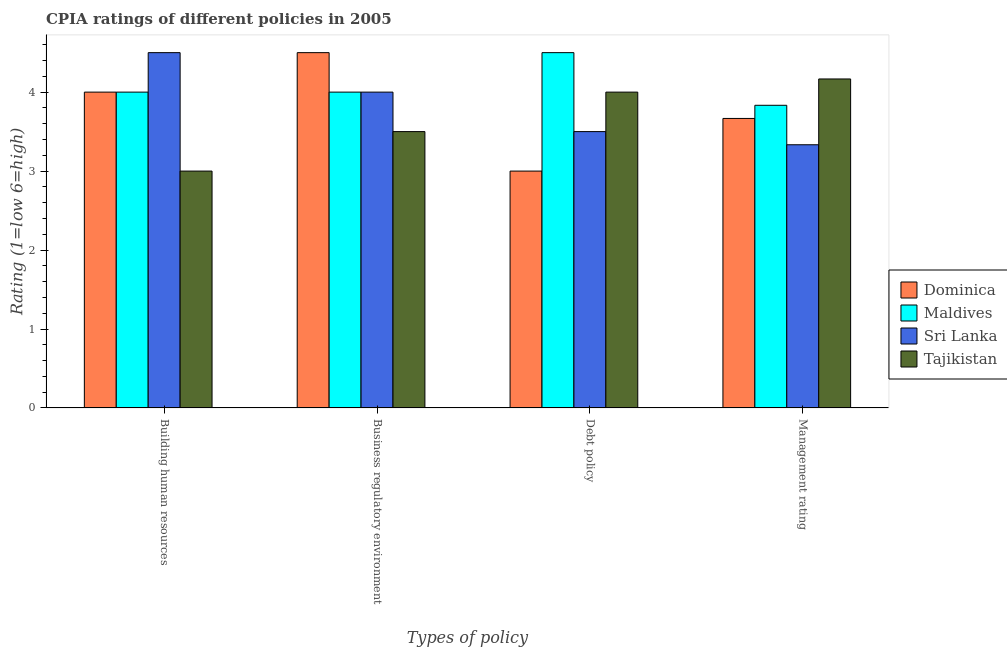Are the number of bars per tick equal to the number of legend labels?
Provide a succinct answer. Yes. How many bars are there on the 3rd tick from the right?
Your answer should be compact. 4. What is the label of the 4th group of bars from the left?
Your answer should be very brief. Management rating. What is the cpia rating of building human resources in Dominica?
Give a very brief answer. 4. Across all countries, what is the maximum cpia rating of management?
Keep it short and to the point. 4.17. In which country was the cpia rating of business regulatory environment maximum?
Ensure brevity in your answer.  Dominica. In which country was the cpia rating of building human resources minimum?
Your answer should be compact. Tajikistan. What is the total cpia rating of building human resources in the graph?
Offer a terse response. 15.5. What is the difference between the cpia rating of building human resources in Sri Lanka and that in Maldives?
Provide a succinct answer. 0.5. What is the difference between the cpia rating of business regulatory environment in Maldives and the cpia rating of management in Tajikistan?
Ensure brevity in your answer.  -0.17. What is the difference between the cpia rating of building human resources and cpia rating of debt policy in Dominica?
Make the answer very short. 1. What is the ratio of the cpia rating of debt policy in Maldives to that in Sri Lanka?
Make the answer very short. 1.29. What is the difference between the highest and the second highest cpia rating of management?
Provide a short and direct response. 0.33. What is the difference between the highest and the lowest cpia rating of business regulatory environment?
Your response must be concise. 1. Is the sum of the cpia rating of management in Maldives and Sri Lanka greater than the maximum cpia rating of debt policy across all countries?
Your answer should be compact. Yes. What does the 2nd bar from the left in Business regulatory environment represents?
Offer a very short reply. Maldives. What does the 3rd bar from the right in Building human resources represents?
Your answer should be very brief. Maldives. How many bars are there?
Ensure brevity in your answer.  16. Are the values on the major ticks of Y-axis written in scientific E-notation?
Ensure brevity in your answer.  No. Does the graph contain any zero values?
Give a very brief answer. No. Does the graph contain grids?
Your answer should be very brief. No. How many legend labels are there?
Provide a short and direct response. 4. How are the legend labels stacked?
Ensure brevity in your answer.  Vertical. What is the title of the graph?
Provide a succinct answer. CPIA ratings of different policies in 2005. What is the label or title of the X-axis?
Provide a short and direct response. Types of policy. What is the label or title of the Y-axis?
Give a very brief answer. Rating (1=low 6=high). What is the Rating (1=low 6=high) of Sri Lanka in Building human resources?
Provide a succinct answer. 4.5. What is the Rating (1=low 6=high) in Tajikistan in Building human resources?
Ensure brevity in your answer.  3. What is the Rating (1=low 6=high) of Sri Lanka in Business regulatory environment?
Offer a very short reply. 4. What is the Rating (1=low 6=high) in Dominica in Debt policy?
Ensure brevity in your answer.  3. What is the Rating (1=low 6=high) in Maldives in Debt policy?
Ensure brevity in your answer.  4.5. What is the Rating (1=low 6=high) in Tajikistan in Debt policy?
Your answer should be compact. 4. What is the Rating (1=low 6=high) in Dominica in Management rating?
Your answer should be compact. 3.67. What is the Rating (1=low 6=high) in Maldives in Management rating?
Offer a very short reply. 3.83. What is the Rating (1=low 6=high) in Sri Lanka in Management rating?
Keep it short and to the point. 3.33. What is the Rating (1=low 6=high) of Tajikistan in Management rating?
Give a very brief answer. 4.17. Across all Types of policy, what is the maximum Rating (1=low 6=high) in Maldives?
Your answer should be compact. 4.5. Across all Types of policy, what is the maximum Rating (1=low 6=high) of Sri Lanka?
Keep it short and to the point. 4.5. Across all Types of policy, what is the maximum Rating (1=low 6=high) of Tajikistan?
Keep it short and to the point. 4.17. Across all Types of policy, what is the minimum Rating (1=low 6=high) in Dominica?
Ensure brevity in your answer.  3. Across all Types of policy, what is the minimum Rating (1=low 6=high) of Maldives?
Provide a succinct answer. 3.83. Across all Types of policy, what is the minimum Rating (1=low 6=high) in Sri Lanka?
Give a very brief answer. 3.33. What is the total Rating (1=low 6=high) in Dominica in the graph?
Your response must be concise. 15.17. What is the total Rating (1=low 6=high) in Maldives in the graph?
Your response must be concise. 16.33. What is the total Rating (1=low 6=high) in Sri Lanka in the graph?
Keep it short and to the point. 15.33. What is the total Rating (1=low 6=high) of Tajikistan in the graph?
Your response must be concise. 14.67. What is the difference between the Rating (1=low 6=high) in Dominica in Building human resources and that in Business regulatory environment?
Provide a succinct answer. -0.5. What is the difference between the Rating (1=low 6=high) in Tajikistan in Building human resources and that in Business regulatory environment?
Your answer should be very brief. -0.5. What is the difference between the Rating (1=low 6=high) in Maldives in Building human resources and that in Debt policy?
Give a very brief answer. -0.5. What is the difference between the Rating (1=low 6=high) in Dominica in Building human resources and that in Management rating?
Make the answer very short. 0.33. What is the difference between the Rating (1=low 6=high) of Tajikistan in Building human resources and that in Management rating?
Give a very brief answer. -1.17. What is the difference between the Rating (1=low 6=high) in Tajikistan in Business regulatory environment and that in Debt policy?
Offer a very short reply. -0.5. What is the difference between the Rating (1=low 6=high) in Dominica in Business regulatory environment and that in Management rating?
Offer a terse response. 0.83. What is the difference between the Rating (1=low 6=high) of Maldives in Business regulatory environment and that in Management rating?
Offer a very short reply. 0.17. What is the difference between the Rating (1=low 6=high) in Sri Lanka in Business regulatory environment and that in Management rating?
Make the answer very short. 0.67. What is the difference between the Rating (1=low 6=high) of Maldives in Debt policy and that in Management rating?
Provide a short and direct response. 0.67. What is the difference between the Rating (1=low 6=high) of Sri Lanka in Debt policy and that in Management rating?
Provide a short and direct response. 0.17. What is the difference between the Rating (1=low 6=high) in Tajikistan in Debt policy and that in Management rating?
Your answer should be very brief. -0.17. What is the difference between the Rating (1=low 6=high) of Dominica in Building human resources and the Rating (1=low 6=high) of Maldives in Business regulatory environment?
Give a very brief answer. 0. What is the difference between the Rating (1=low 6=high) of Maldives in Building human resources and the Rating (1=low 6=high) of Sri Lanka in Business regulatory environment?
Make the answer very short. 0. What is the difference between the Rating (1=low 6=high) in Sri Lanka in Building human resources and the Rating (1=low 6=high) in Tajikistan in Business regulatory environment?
Your answer should be compact. 1. What is the difference between the Rating (1=low 6=high) in Dominica in Building human resources and the Rating (1=low 6=high) in Sri Lanka in Debt policy?
Give a very brief answer. 0.5. What is the difference between the Rating (1=low 6=high) of Maldives in Building human resources and the Rating (1=low 6=high) of Sri Lanka in Debt policy?
Offer a terse response. 0.5. What is the difference between the Rating (1=low 6=high) in Dominica in Building human resources and the Rating (1=low 6=high) in Maldives in Management rating?
Offer a terse response. 0.17. What is the difference between the Rating (1=low 6=high) in Maldives in Building human resources and the Rating (1=low 6=high) in Sri Lanka in Management rating?
Your response must be concise. 0.67. What is the difference between the Rating (1=low 6=high) of Maldives in Building human resources and the Rating (1=low 6=high) of Tajikistan in Management rating?
Provide a succinct answer. -0.17. What is the difference between the Rating (1=low 6=high) in Dominica in Business regulatory environment and the Rating (1=low 6=high) in Sri Lanka in Debt policy?
Provide a short and direct response. 1. What is the difference between the Rating (1=low 6=high) in Maldives in Business regulatory environment and the Rating (1=low 6=high) in Sri Lanka in Debt policy?
Make the answer very short. 0.5. What is the difference between the Rating (1=low 6=high) in Maldives in Business regulatory environment and the Rating (1=low 6=high) in Tajikistan in Debt policy?
Your answer should be very brief. 0. What is the difference between the Rating (1=low 6=high) of Dominica in Business regulatory environment and the Rating (1=low 6=high) of Sri Lanka in Management rating?
Offer a very short reply. 1.17. What is the difference between the Rating (1=low 6=high) in Dominica in Business regulatory environment and the Rating (1=low 6=high) in Tajikistan in Management rating?
Your answer should be compact. 0.33. What is the difference between the Rating (1=low 6=high) in Maldives in Business regulatory environment and the Rating (1=low 6=high) in Sri Lanka in Management rating?
Ensure brevity in your answer.  0.67. What is the difference between the Rating (1=low 6=high) in Maldives in Business regulatory environment and the Rating (1=low 6=high) in Tajikistan in Management rating?
Your response must be concise. -0.17. What is the difference between the Rating (1=low 6=high) of Dominica in Debt policy and the Rating (1=low 6=high) of Tajikistan in Management rating?
Offer a terse response. -1.17. What is the difference between the Rating (1=low 6=high) of Maldives in Debt policy and the Rating (1=low 6=high) of Sri Lanka in Management rating?
Give a very brief answer. 1.17. What is the difference between the Rating (1=low 6=high) in Maldives in Debt policy and the Rating (1=low 6=high) in Tajikistan in Management rating?
Your response must be concise. 0.33. What is the difference between the Rating (1=low 6=high) of Sri Lanka in Debt policy and the Rating (1=low 6=high) of Tajikistan in Management rating?
Provide a succinct answer. -0.67. What is the average Rating (1=low 6=high) of Dominica per Types of policy?
Ensure brevity in your answer.  3.79. What is the average Rating (1=low 6=high) in Maldives per Types of policy?
Provide a short and direct response. 4.08. What is the average Rating (1=low 6=high) in Sri Lanka per Types of policy?
Provide a succinct answer. 3.83. What is the average Rating (1=low 6=high) of Tajikistan per Types of policy?
Your answer should be very brief. 3.67. What is the difference between the Rating (1=low 6=high) in Dominica and Rating (1=low 6=high) in Sri Lanka in Building human resources?
Provide a succinct answer. -0.5. What is the difference between the Rating (1=low 6=high) in Maldives and Rating (1=low 6=high) in Tajikistan in Building human resources?
Your response must be concise. 1. What is the difference between the Rating (1=low 6=high) of Dominica and Rating (1=low 6=high) of Maldives in Business regulatory environment?
Provide a short and direct response. 0.5. What is the difference between the Rating (1=low 6=high) of Dominica and Rating (1=low 6=high) of Tajikistan in Business regulatory environment?
Provide a short and direct response. 1. What is the difference between the Rating (1=low 6=high) in Maldives and Rating (1=low 6=high) in Sri Lanka in Business regulatory environment?
Ensure brevity in your answer.  0. What is the difference between the Rating (1=low 6=high) in Dominica and Rating (1=low 6=high) in Maldives in Debt policy?
Offer a terse response. -1.5. What is the difference between the Rating (1=low 6=high) of Dominica and Rating (1=low 6=high) of Sri Lanka in Debt policy?
Your answer should be compact. -0.5. What is the difference between the Rating (1=low 6=high) in Dominica and Rating (1=low 6=high) in Tajikistan in Debt policy?
Your answer should be compact. -1. What is the difference between the Rating (1=low 6=high) of Sri Lanka and Rating (1=low 6=high) of Tajikistan in Debt policy?
Keep it short and to the point. -0.5. What is the difference between the Rating (1=low 6=high) in Maldives and Rating (1=low 6=high) in Sri Lanka in Management rating?
Make the answer very short. 0.5. What is the ratio of the Rating (1=low 6=high) in Maldives in Building human resources to that in Business regulatory environment?
Offer a terse response. 1. What is the ratio of the Rating (1=low 6=high) in Sri Lanka in Building human resources to that in Business regulatory environment?
Provide a succinct answer. 1.12. What is the ratio of the Rating (1=low 6=high) in Maldives in Building human resources to that in Debt policy?
Give a very brief answer. 0.89. What is the ratio of the Rating (1=low 6=high) of Tajikistan in Building human resources to that in Debt policy?
Offer a very short reply. 0.75. What is the ratio of the Rating (1=low 6=high) in Maldives in Building human resources to that in Management rating?
Ensure brevity in your answer.  1.04. What is the ratio of the Rating (1=low 6=high) in Sri Lanka in Building human resources to that in Management rating?
Your response must be concise. 1.35. What is the ratio of the Rating (1=low 6=high) in Tajikistan in Building human resources to that in Management rating?
Your answer should be compact. 0.72. What is the ratio of the Rating (1=low 6=high) of Maldives in Business regulatory environment to that in Debt policy?
Offer a terse response. 0.89. What is the ratio of the Rating (1=low 6=high) of Tajikistan in Business regulatory environment to that in Debt policy?
Your answer should be very brief. 0.88. What is the ratio of the Rating (1=low 6=high) of Dominica in Business regulatory environment to that in Management rating?
Make the answer very short. 1.23. What is the ratio of the Rating (1=low 6=high) in Maldives in Business regulatory environment to that in Management rating?
Keep it short and to the point. 1.04. What is the ratio of the Rating (1=low 6=high) in Tajikistan in Business regulatory environment to that in Management rating?
Your answer should be very brief. 0.84. What is the ratio of the Rating (1=low 6=high) of Dominica in Debt policy to that in Management rating?
Your response must be concise. 0.82. What is the ratio of the Rating (1=low 6=high) of Maldives in Debt policy to that in Management rating?
Your answer should be compact. 1.17. What is the ratio of the Rating (1=low 6=high) of Sri Lanka in Debt policy to that in Management rating?
Provide a short and direct response. 1.05. What is the difference between the highest and the second highest Rating (1=low 6=high) of Sri Lanka?
Keep it short and to the point. 0.5. What is the difference between the highest and the second highest Rating (1=low 6=high) of Tajikistan?
Your answer should be very brief. 0.17. What is the difference between the highest and the lowest Rating (1=low 6=high) of Dominica?
Provide a short and direct response. 1.5. What is the difference between the highest and the lowest Rating (1=low 6=high) in Tajikistan?
Offer a terse response. 1.17. 